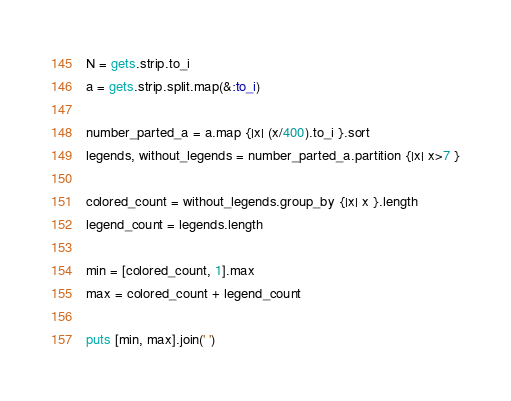Convert code to text. <code><loc_0><loc_0><loc_500><loc_500><_Ruby_>N = gets.strip.to_i
a = gets.strip.split.map(&:to_i)

number_parted_a = a.map {|x| (x/400).to_i }.sort
legends, without_legends = number_parted_a.partition {|x| x>7 }

colored_count = without_legends.group_by {|x| x }.length
legend_count = legends.length

min = [colored_count, 1].max
max = colored_count + legend_count

puts [min, max].join(' ')
</code> 